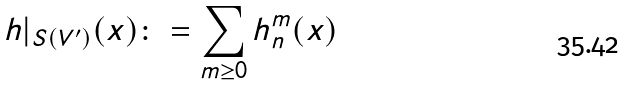Convert formula to latex. <formula><loc_0><loc_0><loc_500><loc_500>h | _ { S ( V ^ { \prime } ) } ( x ) \colon = \sum _ { m \geq 0 } h ^ { m } _ { n } ( x )</formula> 